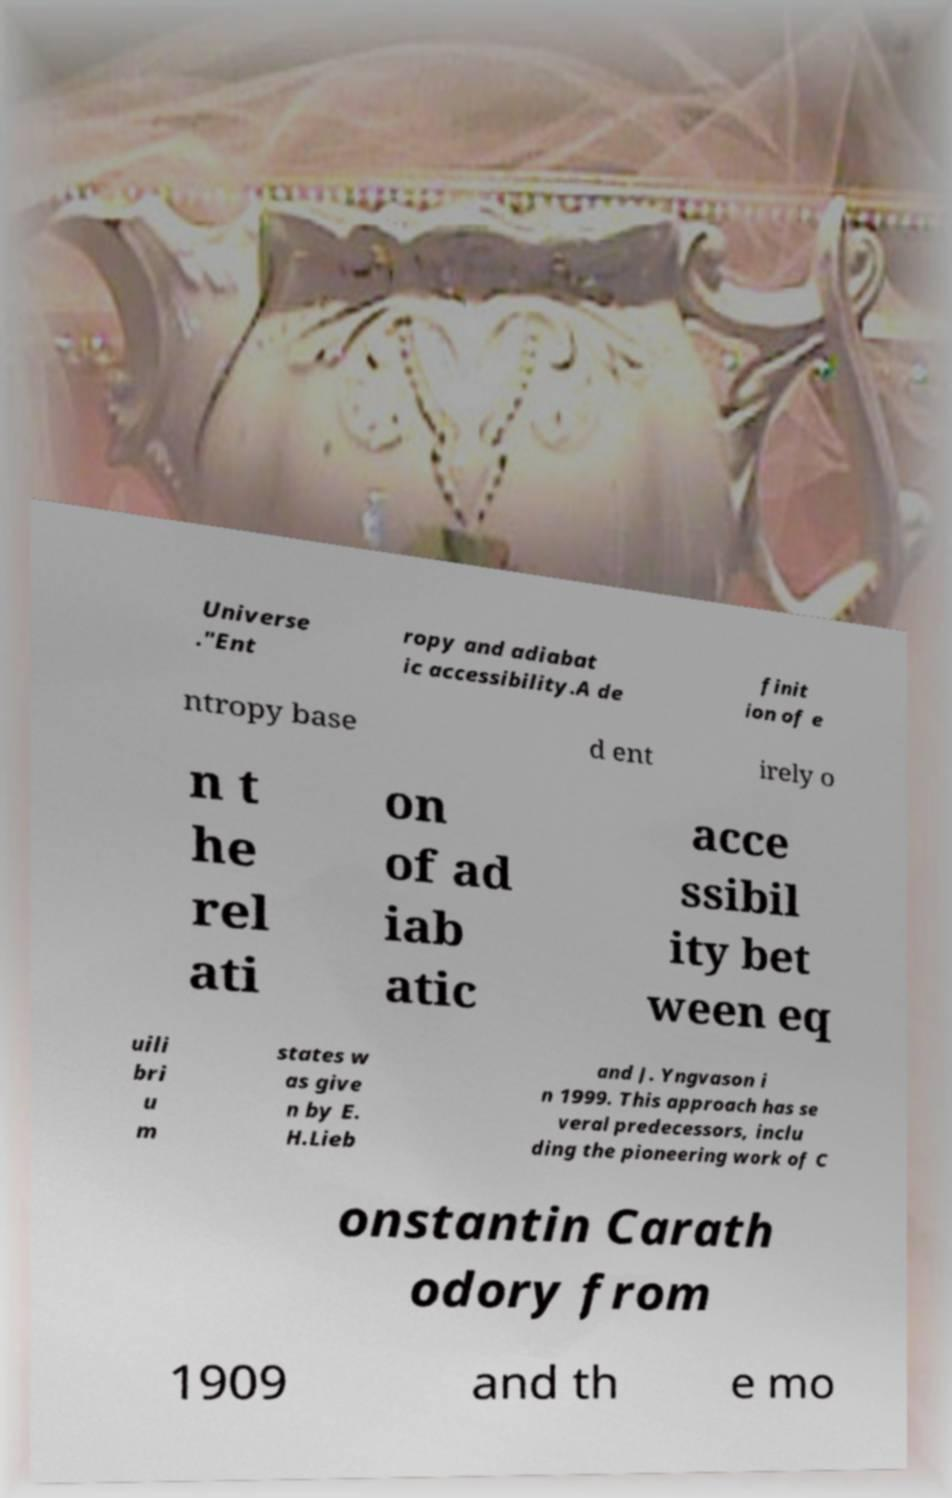Can you read and provide the text displayed in the image?This photo seems to have some interesting text. Can you extract and type it out for me? Universe ."Ent ropy and adiabat ic accessibility.A de finit ion of e ntropy base d ent irely o n t he rel ati on of ad iab atic acce ssibil ity bet ween eq uili bri u m states w as give n by E. H.Lieb and J. Yngvason i n 1999. This approach has se veral predecessors, inclu ding the pioneering work of C onstantin Carath odory from 1909 and th e mo 